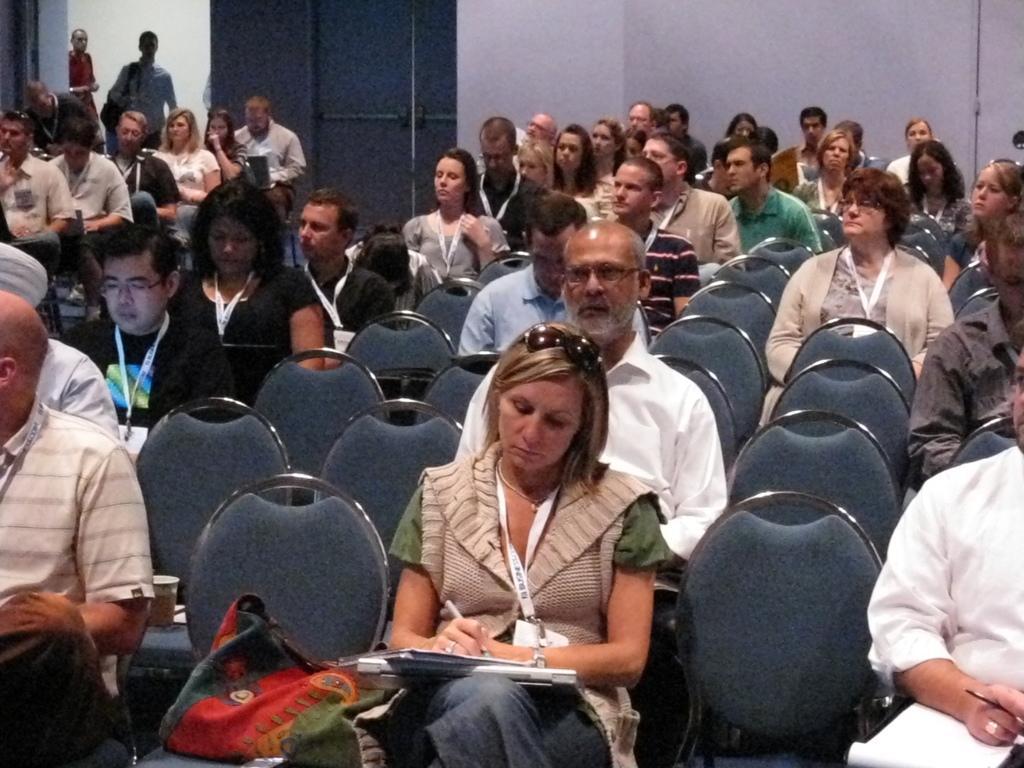Can you describe this image briefly? In this image I can see number of persons are sitting on chairs which are grey in color. I can see few of them are holding pens and books in their hands. In the background I can see few persons standing, the wall and the door. 